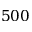Convert formula to latex. <formula><loc_0><loc_0><loc_500><loc_500>5 0 0</formula> 